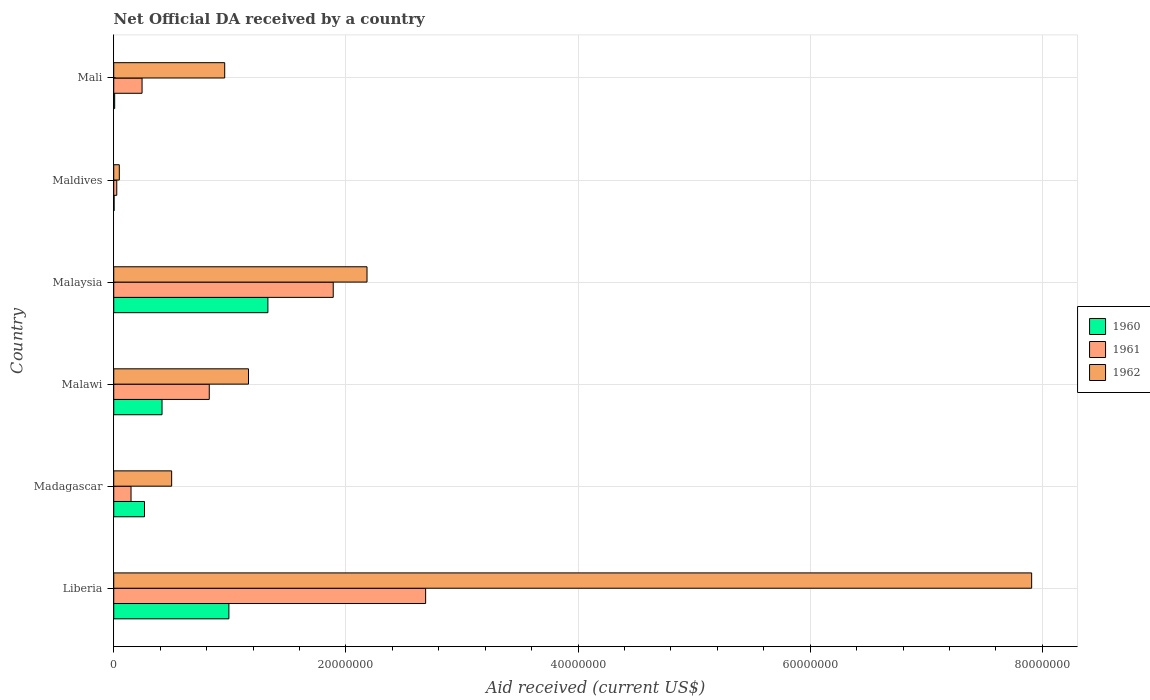How many different coloured bars are there?
Provide a succinct answer. 3. How many groups of bars are there?
Make the answer very short. 6. How many bars are there on the 3rd tick from the top?
Give a very brief answer. 3. How many bars are there on the 2nd tick from the bottom?
Your response must be concise. 3. What is the label of the 2nd group of bars from the top?
Offer a terse response. Maldives. What is the net official development assistance aid received in 1962 in Malawi?
Your response must be concise. 1.16e+07. Across all countries, what is the maximum net official development assistance aid received in 1962?
Your response must be concise. 7.91e+07. Across all countries, what is the minimum net official development assistance aid received in 1960?
Your answer should be compact. 3.00e+04. In which country was the net official development assistance aid received in 1961 maximum?
Give a very brief answer. Liberia. In which country was the net official development assistance aid received in 1962 minimum?
Keep it short and to the point. Maldives. What is the total net official development assistance aid received in 1962 in the graph?
Offer a terse response. 1.28e+08. What is the difference between the net official development assistance aid received in 1960 in Madagascar and that in Malaysia?
Make the answer very short. -1.06e+07. What is the difference between the net official development assistance aid received in 1962 in Malaysia and the net official development assistance aid received in 1961 in Maldives?
Ensure brevity in your answer.  2.16e+07. What is the average net official development assistance aid received in 1960 per country?
Ensure brevity in your answer.  5.02e+06. What is the difference between the net official development assistance aid received in 1960 and net official development assistance aid received in 1961 in Malaysia?
Provide a succinct answer. -5.63e+06. In how many countries, is the net official development assistance aid received in 1961 greater than 60000000 US$?
Make the answer very short. 0. What is the ratio of the net official development assistance aid received in 1961 in Malawi to that in Maldives?
Ensure brevity in your answer.  31.65. Is the difference between the net official development assistance aid received in 1960 in Liberia and Madagascar greater than the difference between the net official development assistance aid received in 1961 in Liberia and Madagascar?
Give a very brief answer. No. What is the difference between the highest and the second highest net official development assistance aid received in 1961?
Your response must be concise. 7.96e+06. What is the difference between the highest and the lowest net official development assistance aid received in 1962?
Offer a very short reply. 7.86e+07. Is the sum of the net official development assistance aid received in 1962 in Malaysia and Maldives greater than the maximum net official development assistance aid received in 1960 across all countries?
Offer a terse response. Yes. What does the 3rd bar from the top in Maldives represents?
Make the answer very short. 1960. Is it the case that in every country, the sum of the net official development assistance aid received in 1962 and net official development assistance aid received in 1961 is greater than the net official development assistance aid received in 1960?
Your answer should be compact. Yes. What is the difference between two consecutive major ticks on the X-axis?
Give a very brief answer. 2.00e+07. Are the values on the major ticks of X-axis written in scientific E-notation?
Your answer should be very brief. No. Does the graph contain grids?
Make the answer very short. Yes. How many legend labels are there?
Offer a very short reply. 3. How are the legend labels stacked?
Keep it short and to the point. Vertical. What is the title of the graph?
Your answer should be compact. Net Official DA received by a country. What is the label or title of the X-axis?
Provide a short and direct response. Aid received (current US$). What is the label or title of the Y-axis?
Ensure brevity in your answer.  Country. What is the Aid received (current US$) of 1960 in Liberia?
Provide a short and direct response. 9.92e+06. What is the Aid received (current US$) in 1961 in Liberia?
Keep it short and to the point. 2.69e+07. What is the Aid received (current US$) of 1962 in Liberia?
Your answer should be compact. 7.91e+07. What is the Aid received (current US$) in 1960 in Madagascar?
Offer a terse response. 2.65e+06. What is the Aid received (current US$) of 1961 in Madagascar?
Give a very brief answer. 1.49e+06. What is the Aid received (current US$) of 1962 in Madagascar?
Give a very brief answer. 4.99e+06. What is the Aid received (current US$) of 1960 in Malawi?
Provide a short and direct response. 4.16e+06. What is the Aid received (current US$) in 1961 in Malawi?
Your answer should be compact. 8.23e+06. What is the Aid received (current US$) in 1962 in Malawi?
Your response must be concise. 1.16e+07. What is the Aid received (current US$) in 1960 in Malaysia?
Your response must be concise. 1.33e+07. What is the Aid received (current US$) of 1961 in Malaysia?
Your response must be concise. 1.89e+07. What is the Aid received (current US$) in 1962 in Malaysia?
Give a very brief answer. 2.18e+07. What is the Aid received (current US$) in 1962 in Maldives?
Your response must be concise. 4.80e+05. What is the Aid received (current US$) of 1961 in Mali?
Keep it short and to the point. 2.44e+06. What is the Aid received (current US$) in 1962 in Mali?
Your response must be concise. 9.56e+06. Across all countries, what is the maximum Aid received (current US$) in 1960?
Make the answer very short. 1.33e+07. Across all countries, what is the maximum Aid received (current US$) of 1961?
Ensure brevity in your answer.  2.69e+07. Across all countries, what is the maximum Aid received (current US$) of 1962?
Your response must be concise. 7.91e+07. Across all countries, what is the minimum Aid received (current US$) of 1961?
Ensure brevity in your answer.  2.60e+05. Across all countries, what is the minimum Aid received (current US$) in 1962?
Your answer should be compact. 4.80e+05. What is the total Aid received (current US$) in 1960 in the graph?
Keep it short and to the point. 3.01e+07. What is the total Aid received (current US$) in 1961 in the graph?
Ensure brevity in your answer.  5.82e+07. What is the total Aid received (current US$) in 1962 in the graph?
Offer a very short reply. 1.28e+08. What is the difference between the Aid received (current US$) of 1960 in Liberia and that in Madagascar?
Offer a very short reply. 7.27e+06. What is the difference between the Aid received (current US$) in 1961 in Liberia and that in Madagascar?
Keep it short and to the point. 2.54e+07. What is the difference between the Aid received (current US$) of 1962 in Liberia and that in Madagascar?
Give a very brief answer. 7.41e+07. What is the difference between the Aid received (current US$) of 1960 in Liberia and that in Malawi?
Keep it short and to the point. 5.76e+06. What is the difference between the Aid received (current US$) in 1961 in Liberia and that in Malawi?
Offer a very short reply. 1.86e+07. What is the difference between the Aid received (current US$) of 1962 in Liberia and that in Malawi?
Your answer should be very brief. 6.75e+07. What is the difference between the Aid received (current US$) in 1960 in Liberia and that in Malaysia?
Offer a terse response. -3.36e+06. What is the difference between the Aid received (current US$) of 1961 in Liberia and that in Malaysia?
Provide a succinct answer. 7.96e+06. What is the difference between the Aid received (current US$) of 1962 in Liberia and that in Malaysia?
Provide a short and direct response. 5.73e+07. What is the difference between the Aid received (current US$) of 1960 in Liberia and that in Maldives?
Make the answer very short. 9.89e+06. What is the difference between the Aid received (current US$) in 1961 in Liberia and that in Maldives?
Ensure brevity in your answer.  2.66e+07. What is the difference between the Aid received (current US$) in 1962 in Liberia and that in Maldives?
Ensure brevity in your answer.  7.86e+07. What is the difference between the Aid received (current US$) in 1960 in Liberia and that in Mali?
Offer a terse response. 9.84e+06. What is the difference between the Aid received (current US$) in 1961 in Liberia and that in Mali?
Your answer should be very brief. 2.44e+07. What is the difference between the Aid received (current US$) in 1962 in Liberia and that in Mali?
Ensure brevity in your answer.  6.95e+07. What is the difference between the Aid received (current US$) in 1960 in Madagascar and that in Malawi?
Ensure brevity in your answer.  -1.51e+06. What is the difference between the Aid received (current US$) of 1961 in Madagascar and that in Malawi?
Your answer should be very brief. -6.74e+06. What is the difference between the Aid received (current US$) of 1962 in Madagascar and that in Malawi?
Ensure brevity in your answer.  -6.62e+06. What is the difference between the Aid received (current US$) in 1960 in Madagascar and that in Malaysia?
Ensure brevity in your answer.  -1.06e+07. What is the difference between the Aid received (current US$) of 1961 in Madagascar and that in Malaysia?
Keep it short and to the point. -1.74e+07. What is the difference between the Aid received (current US$) of 1962 in Madagascar and that in Malaysia?
Ensure brevity in your answer.  -1.68e+07. What is the difference between the Aid received (current US$) in 1960 in Madagascar and that in Maldives?
Keep it short and to the point. 2.62e+06. What is the difference between the Aid received (current US$) of 1961 in Madagascar and that in Maldives?
Give a very brief answer. 1.23e+06. What is the difference between the Aid received (current US$) in 1962 in Madagascar and that in Maldives?
Your answer should be compact. 4.51e+06. What is the difference between the Aid received (current US$) of 1960 in Madagascar and that in Mali?
Your response must be concise. 2.57e+06. What is the difference between the Aid received (current US$) of 1961 in Madagascar and that in Mali?
Ensure brevity in your answer.  -9.50e+05. What is the difference between the Aid received (current US$) of 1962 in Madagascar and that in Mali?
Ensure brevity in your answer.  -4.57e+06. What is the difference between the Aid received (current US$) in 1960 in Malawi and that in Malaysia?
Give a very brief answer. -9.12e+06. What is the difference between the Aid received (current US$) of 1961 in Malawi and that in Malaysia?
Provide a succinct answer. -1.07e+07. What is the difference between the Aid received (current US$) of 1962 in Malawi and that in Malaysia?
Your response must be concise. -1.02e+07. What is the difference between the Aid received (current US$) in 1960 in Malawi and that in Maldives?
Offer a very short reply. 4.13e+06. What is the difference between the Aid received (current US$) in 1961 in Malawi and that in Maldives?
Make the answer very short. 7.97e+06. What is the difference between the Aid received (current US$) in 1962 in Malawi and that in Maldives?
Make the answer very short. 1.11e+07. What is the difference between the Aid received (current US$) of 1960 in Malawi and that in Mali?
Your answer should be very brief. 4.08e+06. What is the difference between the Aid received (current US$) of 1961 in Malawi and that in Mali?
Keep it short and to the point. 5.79e+06. What is the difference between the Aid received (current US$) in 1962 in Malawi and that in Mali?
Offer a terse response. 2.05e+06. What is the difference between the Aid received (current US$) in 1960 in Malaysia and that in Maldives?
Offer a very short reply. 1.32e+07. What is the difference between the Aid received (current US$) in 1961 in Malaysia and that in Maldives?
Ensure brevity in your answer.  1.86e+07. What is the difference between the Aid received (current US$) of 1962 in Malaysia and that in Maldives?
Offer a terse response. 2.13e+07. What is the difference between the Aid received (current US$) in 1960 in Malaysia and that in Mali?
Your answer should be compact. 1.32e+07. What is the difference between the Aid received (current US$) of 1961 in Malaysia and that in Mali?
Your answer should be compact. 1.65e+07. What is the difference between the Aid received (current US$) of 1962 in Malaysia and that in Mali?
Keep it short and to the point. 1.23e+07. What is the difference between the Aid received (current US$) of 1961 in Maldives and that in Mali?
Ensure brevity in your answer.  -2.18e+06. What is the difference between the Aid received (current US$) in 1962 in Maldives and that in Mali?
Your answer should be very brief. -9.08e+06. What is the difference between the Aid received (current US$) in 1960 in Liberia and the Aid received (current US$) in 1961 in Madagascar?
Offer a terse response. 8.43e+06. What is the difference between the Aid received (current US$) in 1960 in Liberia and the Aid received (current US$) in 1962 in Madagascar?
Keep it short and to the point. 4.93e+06. What is the difference between the Aid received (current US$) of 1961 in Liberia and the Aid received (current US$) of 1962 in Madagascar?
Your response must be concise. 2.19e+07. What is the difference between the Aid received (current US$) in 1960 in Liberia and the Aid received (current US$) in 1961 in Malawi?
Your answer should be very brief. 1.69e+06. What is the difference between the Aid received (current US$) of 1960 in Liberia and the Aid received (current US$) of 1962 in Malawi?
Your response must be concise. -1.69e+06. What is the difference between the Aid received (current US$) of 1961 in Liberia and the Aid received (current US$) of 1962 in Malawi?
Ensure brevity in your answer.  1.53e+07. What is the difference between the Aid received (current US$) in 1960 in Liberia and the Aid received (current US$) in 1961 in Malaysia?
Keep it short and to the point. -8.99e+06. What is the difference between the Aid received (current US$) in 1960 in Liberia and the Aid received (current US$) in 1962 in Malaysia?
Your response must be concise. -1.19e+07. What is the difference between the Aid received (current US$) of 1961 in Liberia and the Aid received (current US$) of 1962 in Malaysia?
Keep it short and to the point. 5.05e+06. What is the difference between the Aid received (current US$) of 1960 in Liberia and the Aid received (current US$) of 1961 in Maldives?
Offer a very short reply. 9.66e+06. What is the difference between the Aid received (current US$) in 1960 in Liberia and the Aid received (current US$) in 1962 in Maldives?
Give a very brief answer. 9.44e+06. What is the difference between the Aid received (current US$) of 1961 in Liberia and the Aid received (current US$) of 1962 in Maldives?
Offer a terse response. 2.64e+07. What is the difference between the Aid received (current US$) in 1960 in Liberia and the Aid received (current US$) in 1961 in Mali?
Ensure brevity in your answer.  7.48e+06. What is the difference between the Aid received (current US$) in 1961 in Liberia and the Aid received (current US$) in 1962 in Mali?
Your answer should be very brief. 1.73e+07. What is the difference between the Aid received (current US$) in 1960 in Madagascar and the Aid received (current US$) in 1961 in Malawi?
Your answer should be compact. -5.58e+06. What is the difference between the Aid received (current US$) in 1960 in Madagascar and the Aid received (current US$) in 1962 in Malawi?
Give a very brief answer. -8.96e+06. What is the difference between the Aid received (current US$) in 1961 in Madagascar and the Aid received (current US$) in 1962 in Malawi?
Offer a very short reply. -1.01e+07. What is the difference between the Aid received (current US$) in 1960 in Madagascar and the Aid received (current US$) in 1961 in Malaysia?
Your answer should be very brief. -1.63e+07. What is the difference between the Aid received (current US$) in 1960 in Madagascar and the Aid received (current US$) in 1962 in Malaysia?
Give a very brief answer. -1.92e+07. What is the difference between the Aid received (current US$) of 1961 in Madagascar and the Aid received (current US$) of 1962 in Malaysia?
Offer a terse response. -2.03e+07. What is the difference between the Aid received (current US$) in 1960 in Madagascar and the Aid received (current US$) in 1961 in Maldives?
Offer a very short reply. 2.39e+06. What is the difference between the Aid received (current US$) of 1960 in Madagascar and the Aid received (current US$) of 1962 in Maldives?
Give a very brief answer. 2.17e+06. What is the difference between the Aid received (current US$) in 1961 in Madagascar and the Aid received (current US$) in 1962 in Maldives?
Ensure brevity in your answer.  1.01e+06. What is the difference between the Aid received (current US$) in 1960 in Madagascar and the Aid received (current US$) in 1961 in Mali?
Keep it short and to the point. 2.10e+05. What is the difference between the Aid received (current US$) of 1960 in Madagascar and the Aid received (current US$) of 1962 in Mali?
Provide a succinct answer. -6.91e+06. What is the difference between the Aid received (current US$) of 1961 in Madagascar and the Aid received (current US$) of 1962 in Mali?
Keep it short and to the point. -8.07e+06. What is the difference between the Aid received (current US$) of 1960 in Malawi and the Aid received (current US$) of 1961 in Malaysia?
Your response must be concise. -1.48e+07. What is the difference between the Aid received (current US$) of 1960 in Malawi and the Aid received (current US$) of 1962 in Malaysia?
Ensure brevity in your answer.  -1.77e+07. What is the difference between the Aid received (current US$) of 1961 in Malawi and the Aid received (current US$) of 1962 in Malaysia?
Your answer should be very brief. -1.36e+07. What is the difference between the Aid received (current US$) in 1960 in Malawi and the Aid received (current US$) in 1961 in Maldives?
Give a very brief answer. 3.90e+06. What is the difference between the Aid received (current US$) in 1960 in Malawi and the Aid received (current US$) in 1962 in Maldives?
Give a very brief answer. 3.68e+06. What is the difference between the Aid received (current US$) of 1961 in Malawi and the Aid received (current US$) of 1962 in Maldives?
Your answer should be very brief. 7.75e+06. What is the difference between the Aid received (current US$) in 1960 in Malawi and the Aid received (current US$) in 1961 in Mali?
Ensure brevity in your answer.  1.72e+06. What is the difference between the Aid received (current US$) of 1960 in Malawi and the Aid received (current US$) of 1962 in Mali?
Make the answer very short. -5.40e+06. What is the difference between the Aid received (current US$) of 1961 in Malawi and the Aid received (current US$) of 1962 in Mali?
Your answer should be compact. -1.33e+06. What is the difference between the Aid received (current US$) of 1960 in Malaysia and the Aid received (current US$) of 1961 in Maldives?
Provide a succinct answer. 1.30e+07. What is the difference between the Aid received (current US$) of 1960 in Malaysia and the Aid received (current US$) of 1962 in Maldives?
Your response must be concise. 1.28e+07. What is the difference between the Aid received (current US$) of 1961 in Malaysia and the Aid received (current US$) of 1962 in Maldives?
Offer a very short reply. 1.84e+07. What is the difference between the Aid received (current US$) in 1960 in Malaysia and the Aid received (current US$) in 1961 in Mali?
Your response must be concise. 1.08e+07. What is the difference between the Aid received (current US$) in 1960 in Malaysia and the Aid received (current US$) in 1962 in Mali?
Offer a terse response. 3.72e+06. What is the difference between the Aid received (current US$) in 1961 in Malaysia and the Aid received (current US$) in 1962 in Mali?
Offer a very short reply. 9.35e+06. What is the difference between the Aid received (current US$) of 1960 in Maldives and the Aid received (current US$) of 1961 in Mali?
Ensure brevity in your answer.  -2.41e+06. What is the difference between the Aid received (current US$) in 1960 in Maldives and the Aid received (current US$) in 1962 in Mali?
Keep it short and to the point. -9.53e+06. What is the difference between the Aid received (current US$) in 1961 in Maldives and the Aid received (current US$) in 1962 in Mali?
Your answer should be very brief. -9.30e+06. What is the average Aid received (current US$) in 1960 per country?
Offer a terse response. 5.02e+06. What is the average Aid received (current US$) in 1961 per country?
Ensure brevity in your answer.  9.70e+06. What is the average Aid received (current US$) in 1962 per country?
Give a very brief answer. 2.13e+07. What is the difference between the Aid received (current US$) in 1960 and Aid received (current US$) in 1961 in Liberia?
Make the answer very short. -1.70e+07. What is the difference between the Aid received (current US$) in 1960 and Aid received (current US$) in 1962 in Liberia?
Give a very brief answer. -6.92e+07. What is the difference between the Aid received (current US$) of 1961 and Aid received (current US$) of 1962 in Liberia?
Your answer should be very brief. -5.22e+07. What is the difference between the Aid received (current US$) of 1960 and Aid received (current US$) of 1961 in Madagascar?
Offer a terse response. 1.16e+06. What is the difference between the Aid received (current US$) in 1960 and Aid received (current US$) in 1962 in Madagascar?
Make the answer very short. -2.34e+06. What is the difference between the Aid received (current US$) of 1961 and Aid received (current US$) of 1962 in Madagascar?
Your response must be concise. -3.50e+06. What is the difference between the Aid received (current US$) in 1960 and Aid received (current US$) in 1961 in Malawi?
Offer a very short reply. -4.07e+06. What is the difference between the Aid received (current US$) in 1960 and Aid received (current US$) in 1962 in Malawi?
Keep it short and to the point. -7.45e+06. What is the difference between the Aid received (current US$) of 1961 and Aid received (current US$) of 1962 in Malawi?
Keep it short and to the point. -3.38e+06. What is the difference between the Aid received (current US$) in 1960 and Aid received (current US$) in 1961 in Malaysia?
Make the answer very short. -5.63e+06. What is the difference between the Aid received (current US$) of 1960 and Aid received (current US$) of 1962 in Malaysia?
Provide a short and direct response. -8.54e+06. What is the difference between the Aid received (current US$) in 1961 and Aid received (current US$) in 1962 in Malaysia?
Your response must be concise. -2.91e+06. What is the difference between the Aid received (current US$) in 1960 and Aid received (current US$) in 1962 in Maldives?
Make the answer very short. -4.50e+05. What is the difference between the Aid received (current US$) of 1961 and Aid received (current US$) of 1962 in Maldives?
Keep it short and to the point. -2.20e+05. What is the difference between the Aid received (current US$) of 1960 and Aid received (current US$) of 1961 in Mali?
Your response must be concise. -2.36e+06. What is the difference between the Aid received (current US$) in 1960 and Aid received (current US$) in 1962 in Mali?
Your response must be concise. -9.48e+06. What is the difference between the Aid received (current US$) in 1961 and Aid received (current US$) in 1962 in Mali?
Offer a terse response. -7.12e+06. What is the ratio of the Aid received (current US$) in 1960 in Liberia to that in Madagascar?
Your answer should be very brief. 3.74. What is the ratio of the Aid received (current US$) in 1961 in Liberia to that in Madagascar?
Provide a succinct answer. 18.03. What is the ratio of the Aid received (current US$) in 1962 in Liberia to that in Madagascar?
Make the answer very short. 15.85. What is the ratio of the Aid received (current US$) of 1960 in Liberia to that in Malawi?
Give a very brief answer. 2.38. What is the ratio of the Aid received (current US$) in 1961 in Liberia to that in Malawi?
Provide a succinct answer. 3.26. What is the ratio of the Aid received (current US$) in 1962 in Liberia to that in Malawi?
Provide a short and direct response. 6.81. What is the ratio of the Aid received (current US$) of 1960 in Liberia to that in Malaysia?
Give a very brief answer. 0.75. What is the ratio of the Aid received (current US$) of 1961 in Liberia to that in Malaysia?
Offer a very short reply. 1.42. What is the ratio of the Aid received (current US$) of 1962 in Liberia to that in Malaysia?
Provide a short and direct response. 3.62. What is the ratio of the Aid received (current US$) of 1960 in Liberia to that in Maldives?
Keep it short and to the point. 330.67. What is the ratio of the Aid received (current US$) in 1961 in Liberia to that in Maldives?
Provide a succinct answer. 103.35. What is the ratio of the Aid received (current US$) of 1962 in Liberia to that in Maldives?
Give a very brief answer. 164.75. What is the ratio of the Aid received (current US$) in 1960 in Liberia to that in Mali?
Provide a succinct answer. 124. What is the ratio of the Aid received (current US$) in 1961 in Liberia to that in Mali?
Your answer should be very brief. 11.01. What is the ratio of the Aid received (current US$) of 1962 in Liberia to that in Mali?
Make the answer very short. 8.27. What is the ratio of the Aid received (current US$) in 1960 in Madagascar to that in Malawi?
Your response must be concise. 0.64. What is the ratio of the Aid received (current US$) in 1961 in Madagascar to that in Malawi?
Offer a very short reply. 0.18. What is the ratio of the Aid received (current US$) in 1962 in Madagascar to that in Malawi?
Offer a terse response. 0.43. What is the ratio of the Aid received (current US$) of 1960 in Madagascar to that in Malaysia?
Your answer should be compact. 0.2. What is the ratio of the Aid received (current US$) in 1961 in Madagascar to that in Malaysia?
Provide a short and direct response. 0.08. What is the ratio of the Aid received (current US$) in 1962 in Madagascar to that in Malaysia?
Keep it short and to the point. 0.23. What is the ratio of the Aid received (current US$) in 1960 in Madagascar to that in Maldives?
Offer a terse response. 88.33. What is the ratio of the Aid received (current US$) in 1961 in Madagascar to that in Maldives?
Give a very brief answer. 5.73. What is the ratio of the Aid received (current US$) in 1962 in Madagascar to that in Maldives?
Your answer should be compact. 10.4. What is the ratio of the Aid received (current US$) of 1960 in Madagascar to that in Mali?
Provide a short and direct response. 33.12. What is the ratio of the Aid received (current US$) in 1961 in Madagascar to that in Mali?
Offer a terse response. 0.61. What is the ratio of the Aid received (current US$) of 1962 in Madagascar to that in Mali?
Ensure brevity in your answer.  0.52. What is the ratio of the Aid received (current US$) in 1960 in Malawi to that in Malaysia?
Give a very brief answer. 0.31. What is the ratio of the Aid received (current US$) in 1961 in Malawi to that in Malaysia?
Provide a succinct answer. 0.44. What is the ratio of the Aid received (current US$) in 1962 in Malawi to that in Malaysia?
Your response must be concise. 0.53. What is the ratio of the Aid received (current US$) of 1960 in Malawi to that in Maldives?
Your answer should be compact. 138.67. What is the ratio of the Aid received (current US$) of 1961 in Malawi to that in Maldives?
Provide a succinct answer. 31.65. What is the ratio of the Aid received (current US$) in 1962 in Malawi to that in Maldives?
Make the answer very short. 24.19. What is the ratio of the Aid received (current US$) of 1961 in Malawi to that in Mali?
Offer a terse response. 3.37. What is the ratio of the Aid received (current US$) in 1962 in Malawi to that in Mali?
Give a very brief answer. 1.21. What is the ratio of the Aid received (current US$) in 1960 in Malaysia to that in Maldives?
Your answer should be very brief. 442.67. What is the ratio of the Aid received (current US$) in 1961 in Malaysia to that in Maldives?
Keep it short and to the point. 72.73. What is the ratio of the Aid received (current US$) in 1962 in Malaysia to that in Maldives?
Your answer should be compact. 45.46. What is the ratio of the Aid received (current US$) in 1960 in Malaysia to that in Mali?
Keep it short and to the point. 166. What is the ratio of the Aid received (current US$) of 1961 in Malaysia to that in Mali?
Give a very brief answer. 7.75. What is the ratio of the Aid received (current US$) of 1962 in Malaysia to that in Mali?
Provide a succinct answer. 2.28. What is the ratio of the Aid received (current US$) of 1960 in Maldives to that in Mali?
Keep it short and to the point. 0.38. What is the ratio of the Aid received (current US$) of 1961 in Maldives to that in Mali?
Your answer should be compact. 0.11. What is the ratio of the Aid received (current US$) in 1962 in Maldives to that in Mali?
Offer a very short reply. 0.05. What is the difference between the highest and the second highest Aid received (current US$) of 1960?
Provide a short and direct response. 3.36e+06. What is the difference between the highest and the second highest Aid received (current US$) in 1961?
Provide a short and direct response. 7.96e+06. What is the difference between the highest and the second highest Aid received (current US$) of 1962?
Provide a succinct answer. 5.73e+07. What is the difference between the highest and the lowest Aid received (current US$) of 1960?
Your answer should be very brief. 1.32e+07. What is the difference between the highest and the lowest Aid received (current US$) in 1961?
Your answer should be very brief. 2.66e+07. What is the difference between the highest and the lowest Aid received (current US$) of 1962?
Provide a succinct answer. 7.86e+07. 